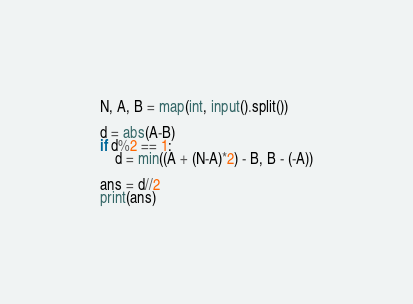Convert code to text. <code><loc_0><loc_0><loc_500><loc_500><_Python_>N, A, B = map(int, input().split())

d = abs(A-B)
if d%2 == 1:
    d = min((A + (N-A)*2) - B, B - (-A))

ans = d//2
print(ans)
</code> 